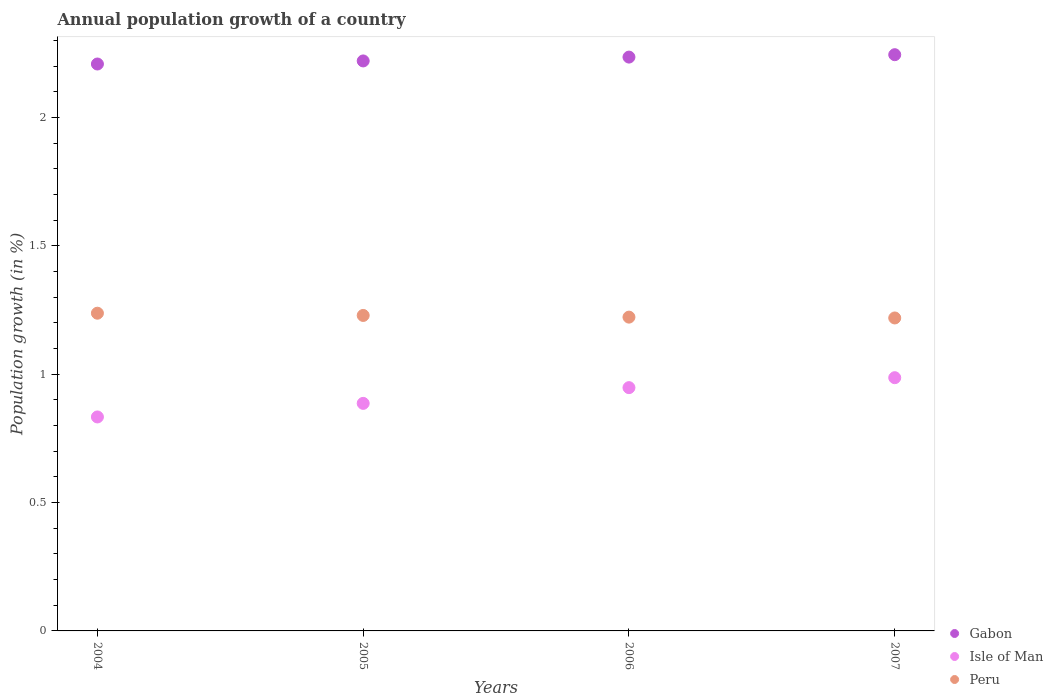How many different coloured dotlines are there?
Make the answer very short. 3. Is the number of dotlines equal to the number of legend labels?
Provide a short and direct response. Yes. What is the annual population growth in Isle of Man in 2007?
Keep it short and to the point. 0.99. Across all years, what is the maximum annual population growth in Gabon?
Offer a very short reply. 2.24. Across all years, what is the minimum annual population growth in Gabon?
Your answer should be compact. 2.21. In which year was the annual population growth in Isle of Man maximum?
Give a very brief answer. 2007. In which year was the annual population growth in Gabon minimum?
Give a very brief answer. 2004. What is the total annual population growth in Isle of Man in the graph?
Provide a short and direct response. 3.65. What is the difference between the annual population growth in Gabon in 2004 and that in 2007?
Keep it short and to the point. -0.04. What is the difference between the annual population growth in Peru in 2006 and the annual population growth in Isle of Man in 2007?
Keep it short and to the point. 0.24. What is the average annual population growth in Isle of Man per year?
Your answer should be very brief. 0.91. In the year 2006, what is the difference between the annual population growth in Isle of Man and annual population growth in Gabon?
Provide a succinct answer. -1.29. What is the ratio of the annual population growth in Gabon in 2005 to that in 2006?
Your answer should be compact. 0.99. What is the difference between the highest and the second highest annual population growth in Peru?
Make the answer very short. 0.01. What is the difference between the highest and the lowest annual population growth in Gabon?
Your answer should be compact. 0.04. In how many years, is the annual population growth in Peru greater than the average annual population growth in Peru taken over all years?
Your response must be concise. 2. Is the sum of the annual population growth in Isle of Man in 2006 and 2007 greater than the maximum annual population growth in Gabon across all years?
Keep it short and to the point. No. Is it the case that in every year, the sum of the annual population growth in Isle of Man and annual population growth in Gabon  is greater than the annual population growth in Peru?
Give a very brief answer. Yes. Does the annual population growth in Peru monotonically increase over the years?
Offer a terse response. No. Is the annual population growth in Peru strictly greater than the annual population growth in Isle of Man over the years?
Keep it short and to the point. Yes. Is the annual population growth in Peru strictly less than the annual population growth in Isle of Man over the years?
Give a very brief answer. No. How many dotlines are there?
Give a very brief answer. 3. How many years are there in the graph?
Keep it short and to the point. 4. What is the difference between two consecutive major ticks on the Y-axis?
Offer a very short reply. 0.5. Are the values on the major ticks of Y-axis written in scientific E-notation?
Provide a succinct answer. No. Does the graph contain any zero values?
Give a very brief answer. No. Does the graph contain grids?
Provide a short and direct response. No. How are the legend labels stacked?
Make the answer very short. Vertical. What is the title of the graph?
Offer a terse response. Annual population growth of a country. What is the label or title of the X-axis?
Your response must be concise. Years. What is the label or title of the Y-axis?
Ensure brevity in your answer.  Population growth (in %). What is the Population growth (in %) in Gabon in 2004?
Provide a succinct answer. 2.21. What is the Population growth (in %) in Isle of Man in 2004?
Offer a very short reply. 0.83. What is the Population growth (in %) of Peru in 2004?
Your answer should be compact. 1.24. What is the Population growth (in %) in Gabon in 2005?
Your response must be concise. 2.22. What is the Population growth (in %) of Isle of Man in 2005?
Provide a succinct answer. 0.89. What is the Population growth (in %) in Peru in 2005?
Give a very brief answer. 1.23. What is the Population growth (in %) in Gabon in 2006?
Keep it short and to the point. 2.24. What is the Population growth (in %) in Isle of Man in 2006?
Your response must be concise. 0.95. What is the Population growth (in %) of Peru in 2006?
Give a very brief answer. 1.22. What is the Population growth (in %) of Gabon in 2007?
Provide a succinct answer. 2.24. What is the Population growth (in %) of Isle of Man in 2007?
Your response must be concise. 0.99. What is the Population growth (in %) in Peru in 2007?
Keep it short and to the point. 1.22. Across all years, what is the maximum Population growth (in %) of Gabon?
Offer a terse response. 2.24. Across all years, what is the maximum Population growth (in %) of Isle of Man?
Keep it short and to the point. 0.99. Across all years, what is the maximum Population growth (in %) in Peru?
Your response must be concise. 1.24. Across all years, what is the minimum Population growth (in %) in Gabon?
Keep it short and to the point. 2.21. Across all years, what is the minimum Population growth (in %) of Isle of Man?
Provide a succinct answer. 0.83. Across all years, what is the minimum Population growth (in %) in Peru?
Offer a terse response. 1.22. What is the total Population growth (in %) in Gabon in the graph?
Offer a very short reply. 8.91. What is the total Population growth (in %) of Isle of Man in the graph?
Make the answer very short. 3.65. What is the total Population growth (in %) of Peru in the graph?
Ensure brevity in your answer.  4.91. What is the difference between the Population growth (in %) in Gabon in 2004 and that in 2005?
Offer a very short reply. -0.01. What is the difference between the Population growth (in %) in Isle of Man in 2004 and that in 2005?
Provide a succinct answer. -0.05. What is the difference between the Population growth (in %) in Peru in 2004 and that in 2005?
Provide a short and direct response. 0.01. What is the difference between the Population growth (in %) of Gabon in 2004 and that in 2006?
Offer a terse response. -0.03. What is the difference between the Population growth (in %) in Isle of Man in 2004 and that in 2006?
Your answer should be compact. -0.11. What is the difference between the Population growth (in %) in Peru in 2004 and that in 2006?
Offer a very short reply. 0.02. What is the difference between the Population growth (in %) in Gabon in 2004 and that in 2007?
Provide a short and direct response. -0.04. What is the difference between the Population growth (in %) of Isle of Man in 2004 and that in 2007?
Your answer should be very brief. -0.15. What is the difference between the Population growth (in %) in Peru in 2004 and that in 2007?
Offer a terse response. 0.02. What is the difference between the Population growth (in %) of Gabon in 2005 and that in 2006?
Your response must be concise. -0.01. What is the difference between the Population growth (in %) in Isle of Man in 2005 and that in 2006?
Offer a terse response. -0.06. What is the difference between the Population growth (in %) in Peru in 2005 and that in 2006?
Provide a succinct answer. 0.01. What is the difference between the Population growth (in %) of Gabon in 2005 and that in 2007?
Ensure brevity in your answer.  -0.02. What is the difference between the Population growth (in %) of Isle of Man in 2005 and that in 2007?
Ensure brevity in your answer.  -0.1. What is the difference between the Population growth (in %) in Peru in 2005 and that in 2007?
Your answer should be very brief. 0.01. What is the difference between the Population growth (in %) in Gabon in 2006 and that in 2007?
Offer a terse response. -0.01. What is the difference between the Population growth (in %) of Isle of Man in 2006 and that in 2007?
Make the answer very short. -0.04. What is the difference between the Population growth (in %) of Peru in 2006 and that in 2007?
Provide a succinct answer. 0. What is the difference between the Population growth (in %) of Gabon in 2004 and the Population growth (in %) of Isle of Man in 2005?
Offer a terse response. 1.32. What is the difference between the Population growth (in %) of Gabon in 2004 and the Population growth (in %) of Peru in 2005?
Make the answer very short. 0.98. What is the difference between the Population growth (in %) in Isle of Man in 2004 and the Population growth (in %) in Peru in 2005?
Make the answer very short. -0.4. What is the difference between the Population growth (in %) in Gabon in 2004 and the Population growth (in %) in Isle of Man in 2006?
Your response must be concise. 1.26. What is the difference between the Population growth (in %) of Gabon in 2004 and the Population growth (in %) of Peru in 2006?
Your answer should be very brief. 0.99. What is the difference between the Population growth (in %) of Isle of Man in 2004 and the Population growth (in %) of Peru in 2006?
Offer a terse response. -0.39. What is the difference between the Population growth (in %) of Gabon in 2004 and the Population growth (in %) of Isle of Man in 2007?
Make the answer very short. 1.22. What is the difference between the Population growth (in %) of Isle of Man in 2004 and the Population growth (in %) of Peru in 2007?
Offer a very short reply. -0.39. What is the difference between the Population growth (in %) in Gabon in 2005 and the Population growth (in %) in Isle of Man in 2006?
Keep it short and to the point. 1.27. What is the difference between the Population growth (in %) in Isle of Man in 2005 and the Population growth (in %) in Peru in 2006?
Provide a short and direct response. -0.34. What is the difference between the Population growth (in %) of Gabon in 2005 and the Population growth (in %) of Isle of Man in 2007?
Offer a very short reply. 1.23. What is the difference between the Population growth (in %) in Gabon in 2005 and the Population growth (in %) in Peru in 2007?
Offer a terse response. 1. What is the difference between the Population growth (in %) of Isle of Man in 2005 and the Population growth (in %) of Peru in 2007?
Provide a succinct answer. -0.33. What is the difference between the Population growth (in %) in Gabon in 2006 and the Population growth (in %) in Isle of Man in 2007?
Your answer should be compact. 1.25. What is the difference between the Population growth (in %) of Gabon in 2006 and the Population growth (in %) of Peru in 2007?
Keep it short and to the point. 1.02. What is the difference between the Population growth (in %) in Isle of Man in 2006 and the Population growth (in %) in Peru in 2007?
Offer a terse response. -0.27. What is the average Population growth (in %) of Gabon per year?
Your answer should be very brief. 2.23. What is the average Population growth (in %) in Isle of Man per year?
Ensure brevity in your answer.  0.91. What is the average Population growth (in %) of Peru per year?
Your response must be concise. 1.23. In the year 2004, what is the difference between the Population growth (in %) of Gabon and Population growth (in %) of Isle of Man?
Make the answer very short. 1.37. In the year 2004, what is the difference between the Population growth (in %) of Gabon and Population growth (in %) of Peru?
Your answer should be very brief. 0.97. In the year 2004, what is the difference between the Population growth (in %) of Isle of Man and Population growth (in %) of Peru?
Give a very brief answer. -0.4. In the year 2005, what is the difference between the Population growth (in %) in Gabon and Population growth (in %) in Isle of Man?
Your response must be concise. 1.33. In the year 2005, what is the difference between the Population growth (in %) of Gabon and Population growth (in %) of Peru?
Provide a short and direct response. 0.99. In the year 2005, what is the difference between the Population growth (in %) in Isle of Man and Population growth (in %) in Peru?
Your response must be concise. -0.34. In the year 2006, what is the difference between the Population growth (in %) of Gabon and Population growth (in %) of Isle of Man?
Your answer should be compact. 1.29. In the year 2006, what is the difference between the Population growth (in %) of Gabon and Population growth (in %) of Peru?
Offer a very short reply. 1.01. In the year 2006, what is the difference between the Population growth (in %) in Isle of Man and Population growth (in %) in Peru?
Give a very brief answer. -0.27. In the year 2007, what is the difference between the Population growth (in %) in Gabon and Population growth (in %) in Isle of Man?
Provide a succinct answer. 1.26. In the year 2007, what is the difference between the Population growth (in %) of Gabon and Population growth (in %) of Peru?
Your answer should be very brief. 1.03. In the year 2007, what is the difference between the Population growth (in %) in Isle of Man and Population growth (in %) in Peru?
Make the answer very short. -0.23. What is the ratio of the Population growth (in %) in Isle of Man in 2004 to that in 2005?
Provide a short and direct response. 0.94. What is the ratio of the Population growth (in %) of Peru in 2004 to that in 2005?
Give a very brief answer. 1.01. What is the ratio of the Population growth (in %) of Isle of Man in 2004 to that in 2006?
Offer a very short reply. 0.88. What is the ratio of the Population growth (in %) in Peru in 2004 to that in 2006?
Give a very brief answer. 1.01. What is the ratio of the Population growth (in %) of Gabon in 2004 to that in 2007?
Your answer should be very brief. 0.98. What is the ratio of the Population growth (in %) of Isle of Man in 2004 to that in 2007?
Offer a terse response. 0.84. What is the ratio of the Population growth (in %) of Peru in 2004 to that in 2007?
Keep it short and to the point. 1.02. What is the ratio of the Population growth (in %) of Isle of Man in 2005 to that in 2006?
Provide a succinct answer. 0.94. What is the ratio of the Population growth (in %) in Peru in 2005 to that in 2006?
Your answer should be very brief. 1.01. What is the ratio of the Population growth (in %) of Gabon in 2005 to that in 2007?
Provide a succinct answer. 0.99. What is the ratio of the Population growth (in %) in Isle of Man in 2005 to that in 2007?
Your answer should be compact. 0.9. What is the ratio of the Population growth (in %) in Gabon in 2006 to that in 2007?
Provide a succinct answer. 1. What is the ratio of the Population growth (in %) of Isle of Man in 2006 to that in 2007?
Keep it short and to the point. 0.96. What is the difference between the highest and the second highest Population growth (in %) in Gabon?
Make the answer very short. 0.01. What is the difference between the highest and the second highest Population growth (in %) of Isle of Man?
Ensure brevity in your answer.  0.04. What is the difference between the highest and the second highest Population growth (in %) in Peru?
Keep it short and to the point. 0.01. What is the difference between the highest and the lowest Population growth (in %) of Gabon?
Your response must be concise. 0.04. What is the difference between the highest and the lowest Population growth (in %) in Isle of Man?
Make the answer very short. 0.15. What is the difference between the highest and the lowest Population growth (in %) of Peru?
Your answer should be very brief. 0.02. 